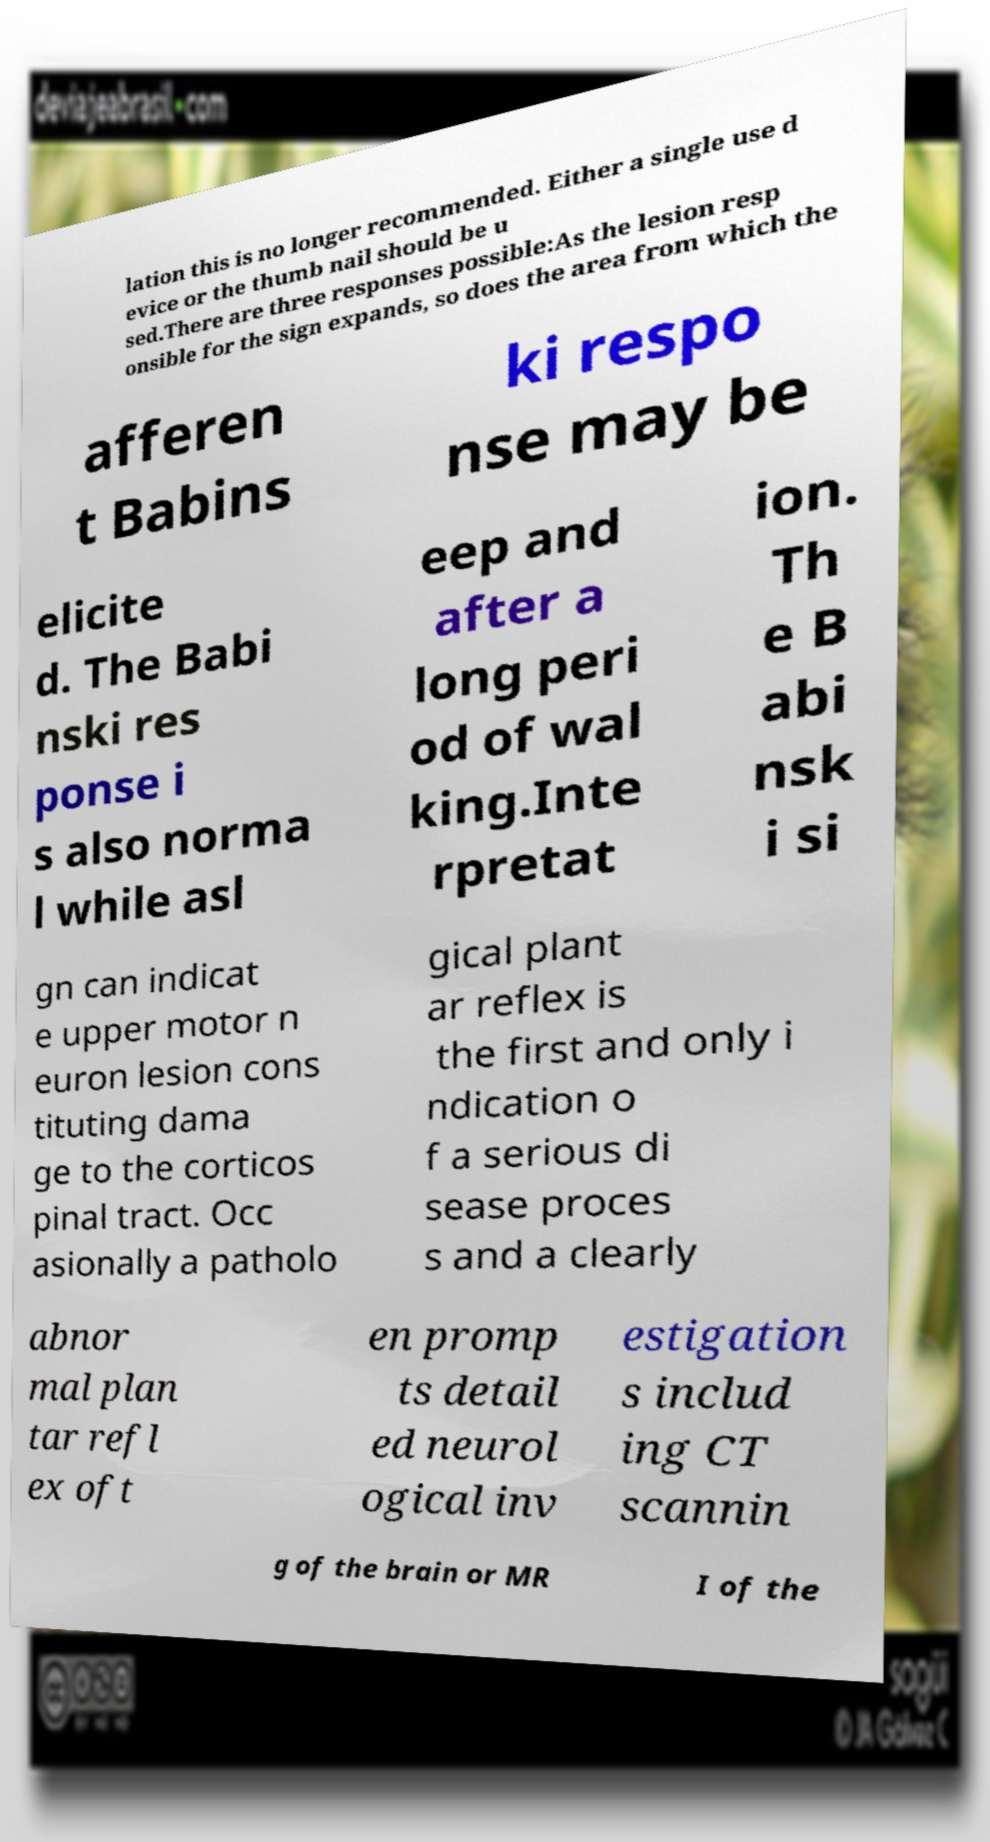Could you extract and type out the text from this image? lation this is no longer recommended. Either a single use d evice or the thumb nail should be u sed.There are three responses possible:As the lesion resp onsible for the sign expands, so does the area from which the afferen t Babins ki respo nse may be elicite d. The Babi nski res ponse i s also norma l while asl eep and after a long peri od of wal king.Inte rpretat ion. Th e B abi nsk i si gn can indicat e upper motor n euron lesion cons tituting dama ge to the corticos pinal tract. Occ asionally a patholo gical plant ar reflex is the first and only i ndication o f a serious di sease proces s and a clearly abnor mal plan tar refl ex oft en promp ts detail ed neurol ogical inv estigation s includ ing CT scannin g of the brain or MR I of the 